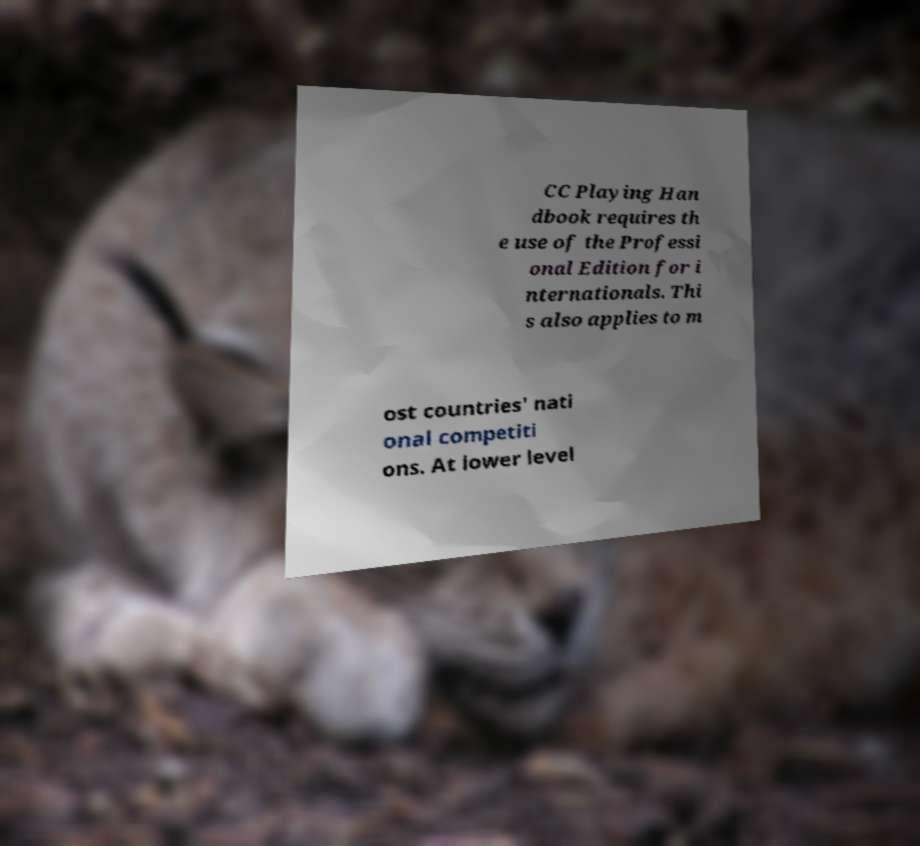Could you extract and type out the text from this image? CC Playing Han dbook requires th e use of the Professi onal Edition for i nternationals. Thi s also applies to m ost countries' nati onal competiti ons. At lower level 